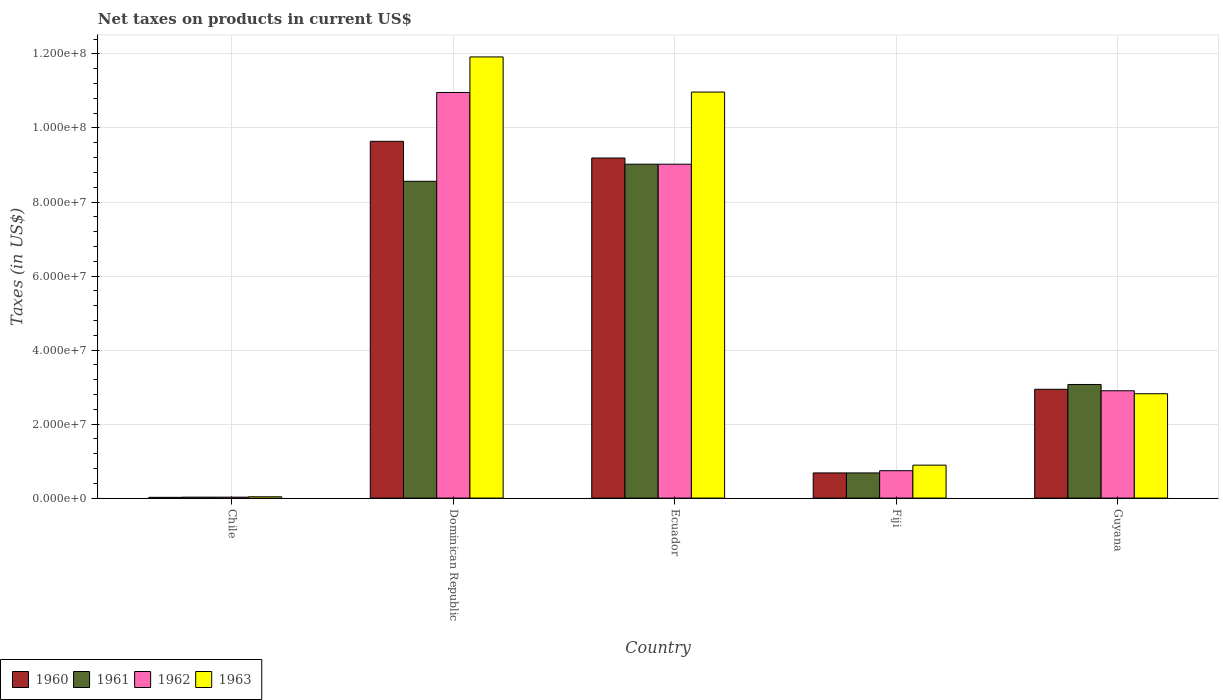How many groups of bars are there?
Provide a succinct answer. 5. Are the number of bars per tick equal to the number of legend labels?
Offer a terse response. Yes. How many bars are there on the 2nd tick from the left?
Offer a very short reply. 4. What is the net taxes on products in 1963 in Dominican Republic?
Your response must be concise. 1.19e+08. Across all countries, what is the maximum net taxes on products in 1963?
Your response must be concise. 1.19e+08. Across all countries, what is the minimum net taxes on products in 1962?
Ensure brevity in your answer.  2.53e+05. In which country was the net taxes on products in 1961 maximum?
Keep it short and to the point. Ecuador. What is the total net taxes on products in 1963 in the graph?
Ensure brevity in your answer.  2.66e+08. What is the difference between the net taxes on products in 1961 in Fiji and that in Guyana?
Keep it short and to the point. -2.39e+07. What is the difference between the net taxes on products in 1961 in Guyana and the net taxes on products in 1960 in Fiji?
Offer a very short reply. 2.39e+07. What is the average net taxes on products in 1963 per country?
Offer a very short reply. 5.33e+07. What is the difference between the net taxes on products of/in 1963 and net taxes on products of/in 1961 in Guyana?
Give a very brief answer. -2.50e+06. In how many countries, is the net taxes on products in 1960 greater than 92000000 US$?
Keep it short and to the point. 1. What is the ratio of the net taxes on products in 1963 in Chile to that in Guyana?
Your response must be concise. 0.01. Is the net taxes on products in 1962 in Ecuador less than that in Guyana?
Your response must be concise. No. Is the difference between the net taxes on products in 1963 in Fiji and Guyana greater than the difference between the net taxes on products in 1961 in Fiji and Guyana?
Your answer should be very brief. Yes. What is the difference between the highest and the second highest net taxes on products in 1960?
Keep it short and to the point. 4.51e+06. What is the difference between the highest and the lowest net taxes on products in 1961?
Offer a terse response. 9.00e+07. In how many countries, is the net taxes on products in 1960 greater than the average net taxes on products in 1960 taken over all countries?
Make the answer very short. 2. What does the 1st bar from the left in Chile represents?
Your response must be concise. 1960. Is it the case that in every country, the sum of the net taxes on products in 1961 and net taxes on products in 1963 is greater than the net taxes on products in 1962?
Offer a terse response. Yes. What is the difference between two consecutive major ticks on the Y-axis?
Your answer should be very brief. 2.00e+07. Does the graph contain any zero values?
Ensure brevity in your answer.  No. Where does the legend appear in the graph?
Offer a very short reply. Bottom left. How many legend labels are there?
Your answer should be very brief. 4. How are the legend labels stacked?
Offer a terse response. Horizontal. What is the title of the graph?
Your answer should be very brief. Net taxes on products in current US$. Does "1977" appear as one of the legend labels in the graph?
Provide a short and direct response. No. What is the label or title of the X-axis?
Keep it short and to the point. Country. What is the label or title of the Y-axis?
Offer a terse response. Taxes (in US$). What is the Taxes (in US$) in 1960 in Chile?
Your answer should be compact. 2.02e+05. What is the Taxes (in US$) in 1961 in Chile?
Provide a short and direct response. 2.53e+05. What is the Taxes (in US$) in 1962 in Chile?
Give a very brief answer. 2.53e+05. What is the Taxes (in US$) in 1963 in Chile?
Ensure brevity in your answer.  3.54e+05. What is the Taxes (in US$) of 1960 in Dominican Republic?
Keep it short and to the point. 9.64e+07. What is the Taxes (in US$) in 1961 in Dominican Republic?
Offer a terse response. 8.56e+07. What is the Taxes (in US$) in 1962 in Dominican Republic?
Give a very brief answer. 1.10e+08. What is the Taxes (in US$) in 1963 in Dominican Republic?
Make the answer very short. 1.19e+08. What is the Taxes (in US$) in 1960 in Ecuador?
Make the answer very short. 9.19e+07. What is the Taxes (in US$) in 1961 in Ecuador?
Provide a succinct answer. 9.02e+07. What is the Taxes (in US$) of 1962 in Ecuador?
Provide a short and direct response. 9.02e+07. What is the Taxes (in US$) of 1963 in Ecuador?
Ensure brevity in your answer.  1.10e+08. What is the Taxes (in US$) in 1960 in Fiji?
Give a very brief answer. 6.80e+06. What is the Taxes (in US$) of 1961 in Fiji?
Your answer should be very brief. 6.80e+06. What is the Taxes (in US$) of 1962 in Fiji?
Ensure brevity in your answer.  7.40e+06. What is the Taxes (in US$) of 1963 in Fiji?
Provide a succinct answer. 8.90e+06. What is the Taxes (in US$) in 1960 in Guyana?
Give a very brief answer. 2.94e+07. What is the Taxes (in US$) of 1961 in Guyana?
Provide a succinct answer. 3.07e+07. What is the Taxes (in US$) in 1962 in Guyana?
Give a very brief answer. 2.90e+07. What is the Taxes (in US$) of 1963 in Guyana?
Keep it short and to the point. 2.82e+07. Across all countries, what is the maximum Taxes (in US$) in 1960?
Your answer should be very brief. 9.64e+07. Across all countries, what is the maximum Taxes (in US$) in 1961?
Make the answer very short. 9.02e+07. Across all countries, what is the maximum Taxes (in US$) of 1962?
Make the answer very short. 1.10e+08. Across all countries, what is the maximum Taxes (in US$) of 1963?
Give a very brief answer. 1.19e+08. Across all countries, what is the minimum Taxes (in US$) of 1960?
Make the answer very short. 2.02e+05. Across all countries, what is the minimum Taxes (in US$) of 1961?
Provide a short and direct response. 2.53e+05. Across all countries, what is the minimum Taxes (in US$) in 1962?
Your answer should be compact. 2.53e+05. Across all countries, what is the minimum Taxes (in US$) in 1963?
Your answer should be very brief. 3.54e+05. What is the total Taxes (in US$) in 1960 in the graph?
Your answer should be very brief. 2.25e+08. What is the total Taxes (in US$) of 1961 in the graph?
Provide a short and direct response. 2.14e+08. What is the total Taxes (in US$) in 1962 in the graph?
Your answer should be very brief. 2.36e+08. What is the total Taxes (in US$) of 1963 in the graph?
Provide a succinct answer. 2.66e+08. What is the difference between the Taxes (in US$) in 1960 in Chile and that in Dominican Republic?
Ensure brevity in your answer.  -9.62e+07. What is the difference between the Taxes (in US$) of 1961 in Chile and that in Dominican Republic?
Your answer should be compact. -8.53e+07. What is the difference between the Taxes (in US$) of 1962 in Chile and that in Dominican Republic?
Keep it short and to the point. -1.09e+08. What is the difference between the Taxes (in US$) in 1963 in Chile and that in Dominican Republic?
Offer a very short reply. -1.19e+08. What is the difference between the Taxes (in US$) of 1960 in Chile and that in Ecuador?
Offer a very short reply. -9.17e+07. What is the difference between the Taxes (in US$) of 1961 in Chile and that in Ecuador?
Ensure brevity in your answer.  -9.00e+07. What is the difference between the Taxes (in US$) of 1962 in Chile and that in Ecuador?
Give a very brief answer. -9.00e+07. What is the difference between the Taxes (in US$) in 1963 in Chile and that in Ecuador?
Give a very brief answer. -1.09e+08. What is the difference between the Taxes (in US$) in 1960 in Chile and that in Fiji?
Give a very brief answer. -6.60e+06. What is the difference between the Taxes (in US$) of 1961 in Chile and that in Fiji?
Your answer should be very brief. -6.55e+06. What is the difference between the Taxes (in US$) of 1962 in Chile and that in Fiji?
Give a very brief answer. -7.15e+06. What is the difference between the Taxes (in US$) in 1963 in Chile and that in Fiji?
Provide a short and direct response. -8.55e+06. What is the difference between the Taxes (in US$) in 1960 in Chile and that in Guyana?
Provide a short and direct response. -2.92e+07. What is the difference between the Taxes (in US$) in 1961 in Chile and that in Guyana?
Your response must be concise. -3.04e+07. What is the difference between the Taxes (in US$) of 1962 in Chile and that in Guyana?
Your response must be concise. -2.87e+07. What is the difference between the Taxes (in US$) in 1963 in Chile and that in Guyana?
Provide a succinct answer. -2.78e+07. What is the difference between the Taxes (in US$) in 1960 in Dominican Republic and that in Ecuador?
Provide a short and direct response. 4.51e+06. What is the difference between the Taxes (in US$) in 1961 in Dominican Republic and that in Ecuador?
Offer a terse response. -4.62e+06. What is the difference between the Taxes (in US$) in 1962 in Dominican Republic and that in Ecuador?
Provide a short and direct response. 1.94e+07. What is the difference between the Taxes (in US$) of 1963 in Dominican Republic and that in Ecuador?
Your answer should be compact. 9.49e+06. What is the difference between the Taxes (in US$) in 1960 in Dominican Republic and that in Fiji?
Your answer should be compact. 8.96e+07. What is the difference between the Taxes (in US$) of 1961 in Dominican Republic and that in Fiji?
Keep it short and to the point. 7.88e+07. What is the difference between the Taxes (in US$) of 1962 in Dominican Republic and that in Fiji?
Your answer should be compact. 1.02e+08. What is the difference between the Taxes (in US$) in 1963 in Dominican Republic and that in Fiji?
Provide a succinct answer. 1.10e+08. What is the difference between the Taxes (in US$) of 1960 in Dominican Republic and that in Guyana?
Make the answer very short. 6.70e+07. What is the difference between the Taxes (in US$) of 1961 in Dominican Republic and that in Guyana?
Provide a succinct answer. 5.49e+07. What is the difference between the Taxes (in US$) of 1962 in Dominican Republic and that in Guyana?
Your answer should be compact. 8.06e+07. What is the difference between the Taxes (in US$) of 1963 in Dominican Republic and that in Guyana?
Offer a terse response. 9.10e+07. What is the difference between the Taxes (in US$) of 1960 in Ecuador and that in Fiji?
Your answer should be compact. 8.51e+07. What is the difference between the Taxes (in US$) of 1961 in Ecuador and that in Fiji?
Your response must be concise. 8.34e+07. What is the difference between the Taxes (in US$) of 1962 in Ecuador and that in Fiji?
Your answer should be compact. 8.28e+07. What is the difference between the Taxes (in US$) in 1963 in Ecuador and that in Fiji?
Keep it short and to the point. 1.01e+08. What is the difference between the Taxes (in US$) in 1960 in Ecuador and that in Guyana?
Your answer should be very brief. 6.25e+07. What is the difference between the Taxes (in US$) of 1961 in Ecuador and that in Guyana?
Offer a terse response. 5.95e+07. What is the difference between the Taxes (in US$) in 1962 in Ecuador and that in Guyana?
Your response must be concise. 6.12e+07. What is the difference between the Taxes (in US$) of 1963 in Ecuador and that in Guyana?
Your answer should be compact. 8.15e+07. What is the difference between the Taxes (in US$) of 1960 in Fiji and that in Guyana?
Your answer should be very brief. -2.26e+07. What is the difference between the Taxes (in US$) of 1961 in Fiji and that in Guyana?
Your answer should be compact. -2.39e+07. What is the difference between the Taxes (in US$) of 1962 in Fiji and that in Guyana?
Keep it short and to the point. -2.16e+07. What is the difference between the Taxes (in US$) of 1963 in Fiji and that in Guyana?
Ensure brevity in your answer.  -1.93e+07. What is the difference between the Taxes (in US$) in 1960 in Chile and the Taxes (in US$) in 1961 in Dominican Republic?
Give a very brief answer. -8.54e+07. What is the difference between the Taxes (in US$) in 1960 in Chile and the Taxes (in US$) in 1962 in Dominican Republic?
Give a very brief answer. -1.09e+08. What is the difference between the Taxes (in US$) of 1960 in Chile and the Taxes (in US$) of 1963 in Dominican Republic?
Your response must be concise. -1.19e+08. What is the difference between the Taxes (in US$) in 1961 in Chile and the Taxes (in US$) in 1962 in Dominican Republic?
Make the answer very short. -1.09e+08. What is the difference between the Taxes (in US$) in 1961 in Chile and the Taxes (in US$) in 1963 in Dominican Republic?
Offer a terse response. -1.19e+08. What is the difference between the Taxes (in US$) in 1962 in Chile and the Taxes (in US$) in 1963 in Dominican Republic?
Give a very brief answer. -1.19e+08. What is the difference between the Taxes (in US$) in 1960 in Chile and the Taxes (in US$) in 1961 in Ecuador?
Offer a very short reply. -9.00e+07. What is the difference between the Taxes (in US$) of 1960 in Chile and the Taxes (in US$) of 1962 in Ecuador?
Your answer should be compact. -9.00e+07. What is the difference between the Taxes (in US$) in 1960 in Chile and the Taxes (in US$) in 1963 in Ecuador?
Offer a very short reply. -1.10e+08. What is the difference between the Taxes (in US$) of 1961 in Chile and the Taxes (in US$) of 1962 in Ecuador?
Give a very brief answer. -9.00e+07. What is the difference between the Taxes (in US$) of 1961 in Chile and the Taxes (in US$) of 1963 in Ecuador?
Your answer should be very brief. -1.09e+08. What is the difference between the Taxes (in US$) in 1962 in Chile and the Taxes (in US$) in 1963 in Ecuador?
Keep it short and to the point. -1.09e+08. What is the difference between the Taxes (in US$) of 1960 in Chile and the Taxes (in US$) of 1961 in Fiji?
Give a very brief answer. -6.60e+06. What is the difference between the Taxes (in US$) of 1960 in Chile and the Taxes (in US$) of 1962 in Fiji?
Make the answer very short. -7.20e+06. What is the difference between the Taxes (in US$) in 1960 in Chile and the Taxes (in US$) in 1963 in Fiji?
Provide a short and direct response. -8.70e+06. What is the difference between the Taxes (in US$) in 1961 in Chile and the Taxes (in US$) in 1962 in Fiji?
Provide a short and direct response. -7.15e+06. What is the difference between the Taxes (in US$) in 1961 in Chile and the Taxes (in US$) in 1963 in Fiji?
Your answer should be very brief. -8.65e+06. What is the difference between the Taxes (in US$) in 1962 in Chile and the Taxes (in US$) in 1963 in Fiji?
Give a very brief answer. -8.65e+06. What is the difference between the Taxes (in US$) of 1960 in Chile and the Taxes (in US$) of 1961 in Guyana?
Your answer should be very brief. -3.05e+07. What is the difference between the Taxes (in US$) of 1960 in Chile and the Taxes (in US$) of 1962 in Guyana?
Your answer should be compact. -2.88e+07. What is the difference between the Taxes (in US$) of 1960 in Chile and the Taxes (in US$) of 1963 in Guyana?
Provide a succinct answer. -2.80e+07. What is the difference between the Taxes (in US$) in 1961 in Chile and the Taxes (in US$) in 1962 in Guyana?
Your answer should be very brief. -2.87e+07. What is the difference between the Taxes (in US$) in 1961 in Chile and the Taxes (in US$) in 1963 in Guyana?
Offer a terse response. -2.79e+07. What is the difference between the Taxes (in US$) in 1962 in Chile and the Taxes (in US$) in 1963 in Guyana?
Offer a terse response. -2.79e+07. What is the difference between the Taxes (in US$) in 1960 in Dominican Republic and the Taxes (in US$) in 1961 in Ecuador?
Make the answer very short. 6.18e+06. What is the difference between the Taxes (in US$) in 1960 in Dominican Republic and the Taxes (in US$) in 1962 in Ecuador?
Your answer should be compact. 6.18e+06. What is the difference between the Taxes (in US$) in 1960 in Dominican Republic and the Taxes (in US$) in 1963 in Ecuador?
Offer a very short reply. -1.33e+07. What is the difference between the Taxes (in US$) of 1961 in Dominican Republic and the Taxes (in US$) of 1962 in Ecuador?
Give a very brief answer. -4.62e+06. What is the difference between the Taxes (in US$) of 1961 in Dominican Republic and the Taxes (in US$) of 1963 in Ecuador?
Provide a short and direct response. -2.41e+07. What is the difference between the Taxes (in US$) in 1962 in Dominican Republic and the Taxes (in US$) in 1963 in Ecuador?
Keep it short and to the point. -1.11e+05. What is the difference between the Taxes (in US$) in 1960 in Dominican Republic and the Taxes (in US$) in 1961 in Fiji?
Provide a short and direct response. 8.96e+07. What is the difference between the Taxes (in US$) of 1960 in Dominican Republic and the Taxes (in US$) of 1962 in Fiji?
Give a very brief answer. 8.90e+07. What is the difference between the Taxes (in US$) of 1960 in Dominican Republic and the Taxes (in US$) of 1963 in Fiji?
Your answer should be compact. 8.75e+07. What is the difference between the Taxes (in US$) of 1961 in Dominican Republic and the Taxes (in US$) of 1962 in Fiji?
Give a very brief answer. 7.82e+07. What is the difference between the Taxes (in US$) of 1961 in Dominican Republic and the Taxes (in US$) of 1963 in Fiji?
Keep it short and to the point. 7.67e+07. What is the difference between the Taxes (in US$) in 1962 in Dominican Republic and the Taxes (in US$) in 1963 in Fiji?
Ensure brevity in your answer.  1.01e+08. What is the difference between the Taxes (in US$) of 1960 in Dominican Republic and the Taxes (in US$) of 1961 in Guyana?
Your answer should be very brief. 6.57e+07. What is the difference between the Taxes (in US$) in 1960 in Dominican Republic and the Taxes (in US$) in 1962 in Guyana?
Your answer should be compact. 6.74e+07. What is the difference between the Taxes (in US$) in 1960 in Dominican Republic and the Taxes (in US$) in 1963 in Guyana?
Provide a succinct answer. 6.82e+07. What is the difference between the Taxes (in US$) of 1961 in Dominican Republic and the Taxes (in US$) of 1962 in Guyana?
Ensure brevity in your answer.  5.66e+07. What is the difference between the Taxes (in US$) of 1961 in Dominican Republic and the Taxes (in US$) of 1963 in Guyana?
Your answer should be very brief. 5.74e+07. What is the difference between the Taxes (in US$) in 1962 in Dominican Republic and the Taxes (in US$) in 1963 in Guyana?
Give a very brief answer. 8.14e+07. What is the difference between the Taxes (in US$) of 1960 in Ecuador and the Taxes (in US$) of 1961 in Fiji?
Make the answer very short. 8.51e+07. What is the difference between the Taxes (in US$) in 1960 in Ecuador and the Taxes (in US$) in 1962 in Fiji?
Your answer should be compact. 8.45e+07. What is the difference between the Taxes (in US$) of 1960 in Ecuador and the Taxes (in US$) of 1963 in Fiji?
Offer a very short reply. 8.30e+07. What is the difference between the Taxes (in US$) of 1961 in Ecuador and the Taxes (in US$) of 1962 in Fiji?
Offer a terse response. 8.28e+07. What is the difference between the Taxes (in US$) of 1961 in Ecuador and the Taxes (in US$) of 1963 in Fiji?
Your answer should be very brief. 8.13e+07. What is the difference between the Taxes (in US$) in 1962 in Ecuador and the Taxes (in US$) in 1963 in Fiji?
Provide a succinct answer. 8.13e+07. What is the difference between the Taxes (in US$) of 1960 in Ecuador and the Taxes (in US$) of 1961 in Guyana?
Ensure brevity in your answer.  6.12e+07. What is the difference between the Taxes (in US$) in 1960 in Ecuador and the Taxes (in US$) in 1962 in Guyana?
Give a very brief answer. 6.29e+07. What is the difference between the Taxes (in US$) of 1960 in Ecuador and the Taxes (in US$) of 1963 in Guyana?
Offer a very short reply. 6.37e+07. What is the difference between the Taxes (in US$) of 1961 in Ecuador and the Taxes (in US$) of 1962 in Guyana?
Offer a terse response. 6.12e+07. What is the difference between the Taxes (in US$) of 1961 in Ecuador and the Taxes (in US$) of 1963 in Guyana?
Ensure brevity in your answer.  6.20e+07. What is the difference between the Taxes (in US$) of 1962 in Ecuador and the Taxes (in US$) of 1963 in Guyana?
Offer a very short reply. 6.20e+07. What is the difference between the Taxes (in US$) in 1960 in Fiji and the Taxes (in US$) in 1961 in Guyana?
Your answer should be compact. -2.39e+07. What is the difference between the Taxes (in US$) in 1960 in Fiji and the Taxes (in US$) in 1962 in Guyana?
Your answer should be very brief. -2.22e+07. What is the difference between the Taxes (in US$) in 1960 in Fiji and the Taxes (in US$) in 1963 in Guyana?
Your answer should be very brief. -2.14e+07. What is the difference between the Taxes (in US$) of 1961 in Fiji and the Taxes (in US$) of 1962 in Guyana?
Your answer should be compact. -2.22e+07. What is the difference between the Taxes (in US$) in 1961 in Fiji and the Taxes (in US$) in 1963 in Guyana?
Give a very brief answer. -2.14e+07. What is the difference between the Taxes (in US$) of 1962 in Fiji and the Taxes (in US$) of 1963 in Guyana?
Make the answer very short. -2.08e+07. What is the average Taxes (in US$) of 1960 per country?
Your response must be concise. 4.49e+07. What is the average Taxes (in US$) in 1961 per country?
Ensure brevity in your answer.  4.27e+07. What is the average Taxes (in US$) in 1962 per country?
Your answer should be very brief. 4.73e+07. What is the average Taxes (in US$) in 1963 per country?
Ensure brevity in your answer.  5.33e+07. What is the difference between the Taxes (in US$) in 1960 and Taxes (in US$) in 1961 in Chile?
Give a very brief answer. -5.06e+04. What is the difference between the Taxes (in US$) of 1960 and Taxes (in US$) of 1962 in Chile?
Keep it short and to the point. -5.06e+04. What is the difference between the Taxes (in US$) of 1960 and Taxes (in US$) of 1963 in Chile?
Your answer should be compact. -1.52e+05. What is the difference between the Taxes (in US$) in 1961 and Taxes (in US$) in 1962 in Chile?
Your response must be concise. 0. What is the difference between the Taxes (in US$) of 1961 and Taxes (in US$) of 1963 in Chile?
Offer a very short reply. -1.01e+05. What is the difference between the Taxes (in US$) of 1962 and Taxes (in US$) of 1963 in Chile?
Ensure brevity in your answer.  -1.01e+05. What is the difference between the Taxes (in US$) of 1960 and Taxes (in US$) of 1961 in Dominican Republic?
Offer a terse response. 1.08e+07. What is the difference between the Taxes (in US$) in 1960 and Taxes (in US$) in 1962 in Dominican Republic?
Ensure brevity in your answer.  -1.32e+07. What is the difference between the Taxes (in US$) of 1960 and Taxes (in US$) of 1963 in Dominican Republic?
Ensure brevity in your answer.  -2.28e+07. What is the difference between the Taxes (in US$) of 1961 and Taxes (in US$) of 1962 in Dominican Republic?
Give a very brief answer. -2.40e+07. What is the difference between the Taxes (in US$) of 1961 and Taxes (in US$) of 1963 in Dominican Republic?
Ensure brevity in your answer.  -3.36e+07. What is the difference between the Taxes (in US$) of 1962 and Taxes (in US$) of 1963 in Dominican Republic?
Offer a very short reply. -9.60e+06. What is the difference between the Taxes (in US$) in 1960 and Taxes (in US$) in 1961 in Ecuador?
Your answer should be very brief. 1.67e+06. What is the difference between the Taxes (in US$) in 1960 and Taxes (in US$) in 1962 in Ecuador?
Your response must be concise. 1.67e+06. What is the difference between the Taxes (in US$) in 1960 and Taxes (in US$) in 1963 in Ecuador?
Provide a succinct answer. -1.78e+07. What is the difference between the Taxes (in US$) of 1961 and Taxes (in US$) of 1963 in Ecuador?
Keep it short and to the point. -1.95e+07. What is the difference between the Taxes (in US$) of 1962 and Taxes (in US$) of 1963 in Ecuador?
Give a very brief answer. -1.95e+07. What is the difference between the Taxes (in US$) of 1960 and Taxes (in US$) of 1961 in Fiji?
Offer a very short reply. 0. What is the difference between the Taxes (in US$) in 1960 and Taxes (in US$) in 1962 in Fiji?
Your answer should be compact. -6.00e+05. What is the difference between the Taxes (in US$) in 1960 and Taxes (in US$) in 1963 in Fiji?
Offer a very short reply. -2.10e+06. What is the difference between the Taxes (in US$) in 1961 and Taxes (in US$) in 1962 in Fiji?
Make the answer very short. -6.00e+05. What is the difference between the Taxes (in US$) in 1961 and Taxes (in US$) in 1963 in Fiji?
Make the answer very short. -2.10e+06. What is the difference between the Taxes (in US$) of 1962 and Taxes (in US$) of 1963 in Fiji?
Ensure brevity in your answer.  -1.50e+06. What is the difference between the Taxes (in US$) in 1960 and Taxes (in US$) in 1961 in Guyana?
Provide a short and direct response. -1.30e+06. What is the difference between the Taxes (in US$) in 1960 and Taxes (in US$) in 1963 in Guyana?
Make the answer very short. 1.20e+06. What is the difference between the Taxes (in US$) of 1961 and Taxes (in US$) of 1962 in Guyana?
Provide a short and direct response. 1.70e+06. What is the difference between the Taxes (in US$) of 1961 and Taxes (in US$) of 1963 in Guyana?
Provide a succinct answer. 2.50e+06. What is the ratio of the Taxes (in US$) in 1960 in Chile to that in Dominican Republic?
Give a very brief answer. 0. What is the ratio of the Taxes (in US$) in 1961 in Chile to that in Dominican Republic?
Your answer should be very brief. 0. What is the ratio of the Taxes (in US$) of 1962 in Chile to that in Dominican Republic?
Offer a terse response. 0. What is the ratio of the Taxes (in US$) in 1963 in Chile to that in Dominican Republic?
Keep it short and to the point. 0. What is the ratio of the Taxes (in US$) in 1960 in Chile to that in Ecuador?
Your answer should be compact. 0. What is the ratio of the Taxes (in US$) of 1961 in Chile to that in Ecuador?
Offer a terse response. 0. What is the ratio of the Taxes (in US$) in 1962 in Chile to that in Ecuador?
Keep it short and to the point. 0. What is the ratio of the Taxes (in US$) in 1963 in Chile to that in Ecuador?
Your response must be concise. 0. What is the ratio of the Taxes (in US$) in 1960 in Chile to that in Fiji?
Offer a very short reply. 0.03. What is the ratio of the Taxes (in US$) of 1961 in Chile to that in Fiji?
Offer a terse response. 0.04. What is the ratio of the Taxes (in US$) of 1962 in Chile to that in Fiji?
Provide a short and direct response. 0.03. What is the ratio of the Taxes (in US$) of 1963 in Chile to that in Fiji?
Your answer should be compact. 0.04. What is the ratio of the Taxes (in US$) in 1960 in Chile to that in Guyana?
Provide a short and direct response. 0.01. What is the ratio of the Taxes (in US$) in 1961 in Chile to that in Guyana?
Give a very brief answer. 0.01. What is the ratio of the Taxes (in US$) in 1962 in Chile to that in Guyana?
Offer a terse response. 0.01. What is the ratio of the Taxes (in US$) of 1963 in Chile to that in Guyana?
Offer a very short reply. 0.01. What is the ratio of the Taxes (in US$) in 1960 in Dominican Republic to that in Ecuador?
Provide a short and direct response. 1.05. What is the ratio of the Taxes (in US$) of 1961 in Dominican Republic to that in Ecuador?
Offer a very short reply. 0.95. What is the ratio of the Taxes (in US$) in 1962 in Dominican Republic to that in Ecuador?
Your response must be concise. 1.21. What is the ratio of the Taxes (in US$) of 1963 in Dominican Republic to that in Ecuador?
Your answer should be very brief. 1.09. What is the ratio of the Taxes (in US$) of 1960 in Dominican Republic to that in Fiji?
Your answer should be compact. 14.18. What is the ratio of the Taxes (in US$) in 1961 in Dominican Republic to that in Fiji?
Make the answer very short. 12.59. What is the ratio of the Taxes (in US$) in 1962 in Dominican Republic to that in Fiji?
Offer a terse response. 14.81. What is the ratio of the Taxes (in US$) in 1963 in Dominican Republic to that in Fiji?
Provide a succinct answer. 13.39. What is the ratio of the Taxes (in US$) of 1960 in Dominican Republic to that in Guyana?
Ensure brevity in your answer.  3.28. What is the ratio of the Taxes (in US$) of 1961 in Dominican Republic to that in Guyana?
Provide a succinct answer. 2.79. What is the ratio of the Taxes (in US$) in 1962 in Dominican Republic to that in Guyana?
Keep it short and to the point. 3.78. What is the ratio of the Taxes (in US$) in 1963 in Dominican Republic to that in Guyana?
Make the answer very short. 4.23. What is the ratio of the Taxes (in US$) in 1960 in Ecuador to that in Fiji?
Make the answer very short. 13.51. What is the ratio of the Taxes (in US$) of 1961 in Ecuador to that in Fiji?
Your answer should be very brief. 13.27. What is the ratio of the Taxes (in US$) of 1962 in Ecuador to that in Fiji?
Your answer should be very brief. 12.19. What is the ratio of the Taxes (in US$) in 1963 in Ecuador to that in Fiji?
Your answer should be very brief. 12.33. What is the ratio of the Taxes (in US$) of 1960 in Ecuador to that in Guyana?
Your response must be concise. 3.13. What is the ratio of the Taxes (in US$) in 1961 in Ecuador to that in Guyana?
Your response must be concise. 2.94. What is the ratio of the Taxes (in US$) in 1962 in Ecuador to that in Guyana?
Ensure brevity in your answer.  3.11. What is the ratio of the Taxes (in US$) of 1963 in Ecuador to that in Guyana?
Give a very brief answer. 3.89. What is the ratio of the Taxes (in US$) of 1960 in Fiji to that in Guyana?
Make the answer very short. 0.23. What is the ratio of the Taxes (in US$) in 1961 in Fiji to that in Guyana?
Offer a very short reply. 0.22. What is the ratio of the Taxes (in US$) of 1962 in Fiji to that in Guyana?
Keep it short and to the point. 0.26. What is the ratio of the Taxes (in US$) in 1963 in Fiji to that in Guyana?
Ensure brevity in your answer.  0.32. What is the difference between the highest and the second highest Taxes (in US$) in 1960?
Ensure brevity in your answer.  4.51e+06. What is the difference between the highest and the second highest Taxes (in US$) in 1961?
Offer a very short reply. 4.62e+06. What is the difference between the highest and the second highest Taxes (in US$) of 1962?
Offer a terse response. 1.94e+07. What is the difference between the highest and the second highest Taxes (in US$) in 1963?
Your response must be concise. 9.49e+06. What is the difference between the highest and the lowest Taxes (in US$) of 1960?
Give a very brief answer. 9.62e+07. What is the difference between the highest and the lowest Taxes (in US$) in 1961?
Keep it short and to the point. 9.00e+07. What is the difference between the highest and the lowest Taxes (in US$) in 1962?
Offer a terse response. 1.09e+08. What is the difference between the highest and the lowest Taxes (in US$) in 1963?
Keep it short and to the point. 1.19e+08. 